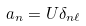<formula> <loc_0><loc_0><loc_500><loc_500>a _ { n } = U \delta _ { n \ell }</formula> 